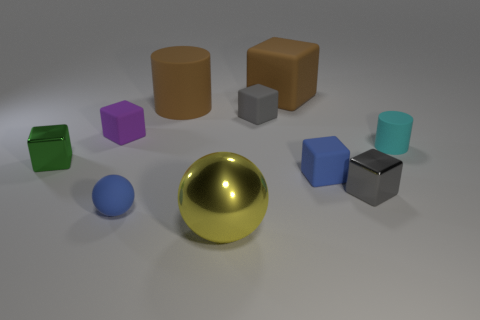How many other things are there of the same size as the cyan cylinder? Including the cyan cylinder, there are a total of seven objects that appear to share a similar size. The objects consist of two cylinders, two cubes, and three rectangular boxes. 